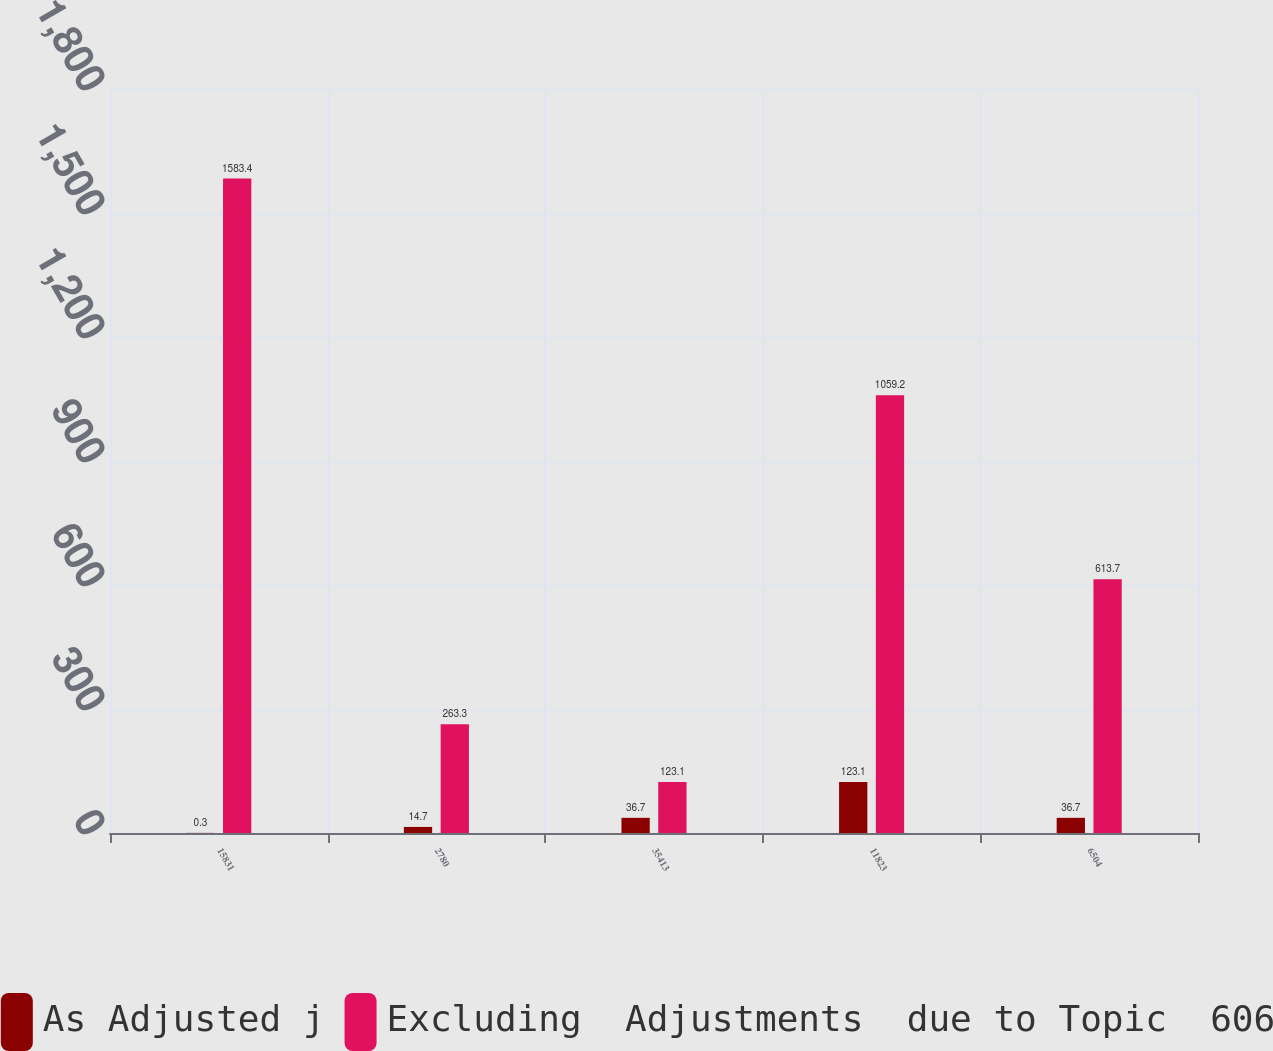Convert chart. <chart><loc_0><loc_0><loc_500><loc_500><stacked_bar_chart><ecel><fcel>15831<fcel>2780<fcel>35413<fcel>11823<fcel>6504<nl><fcel>As Adjusted j<fcel>0.3<fcel>14.7<fcel>36.7<fcel>123.1<fcel>36.7<nl><fcel>Excluding  Adjustments  due to Topic  606<fcel>1583.4<fcel>263.3<fcel>123.1<fcel>1059.2<fcel>613.7<nl></chart> 